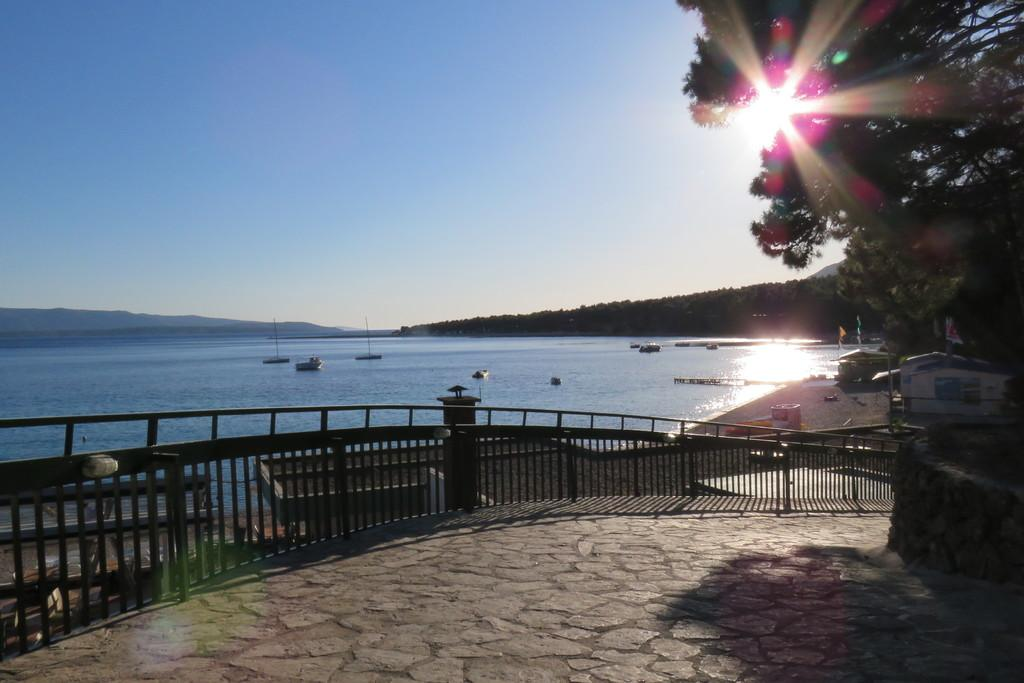What type of body of water is present in the image? There is a sea in the image. What can be seen floating on the sea? There are boats in the sea. What type of path is visible in the image? There is a footpath in the image. What structure is present to separate or enclose an area? There is a fence in the image. What type of vegetation is present in the image? There are trees in the image. What part of the natural environment is visible in the image? The sky is visible in the image. What celestial body is visible in the sky? The sun is visible in the image. What type of building is present in the image? There is a house in the image. What type of sign is present in the image? There is a banner in the image. What type of terrain is present near the sea? There is sand in the image. What type of news can be seen on the banner in the image? There is no news present on the banner in the image; it is not mentioned in the provided facts. What type of tool is used for digging in the image? There is no tool for digging present in the image; it is not mentioned in the provided facts. 